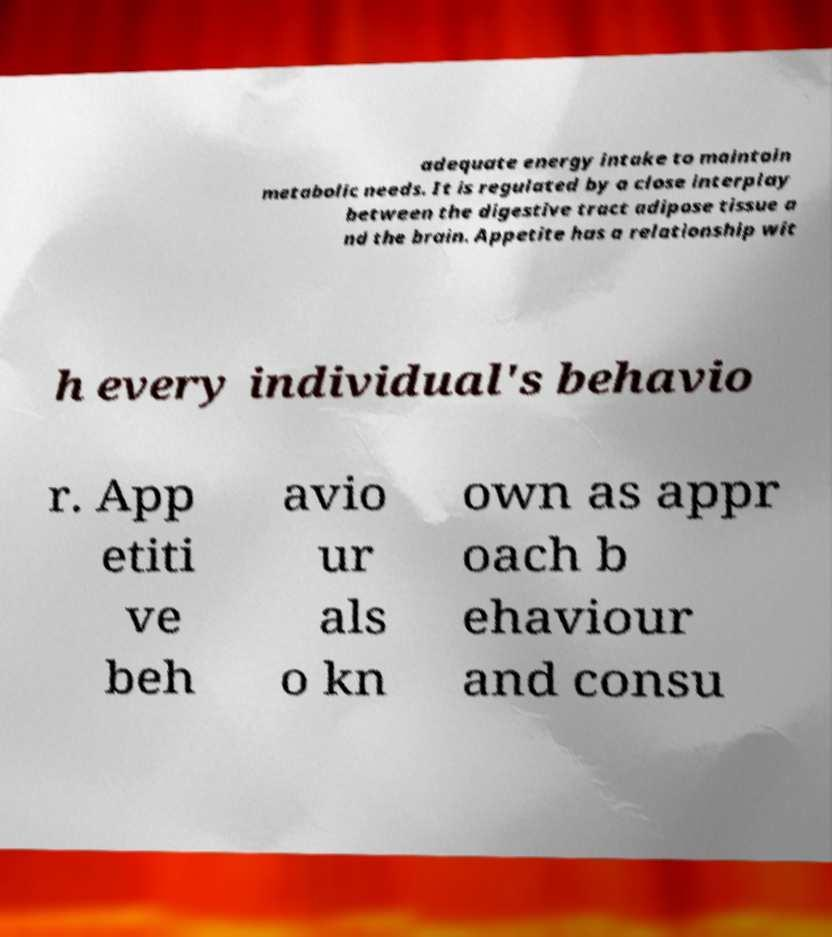I need the written content from this picture converted into text. Can you do that? adequate energy intake to maintain metabolic needs. It is regulated by a close interplay between the digestive tract adipose tissue a nd the brain. Appetite has a relationship wit h every individual's behavio r. App etiti ve beh avio ur als o kn own as appr oach b ehaviour and consu 